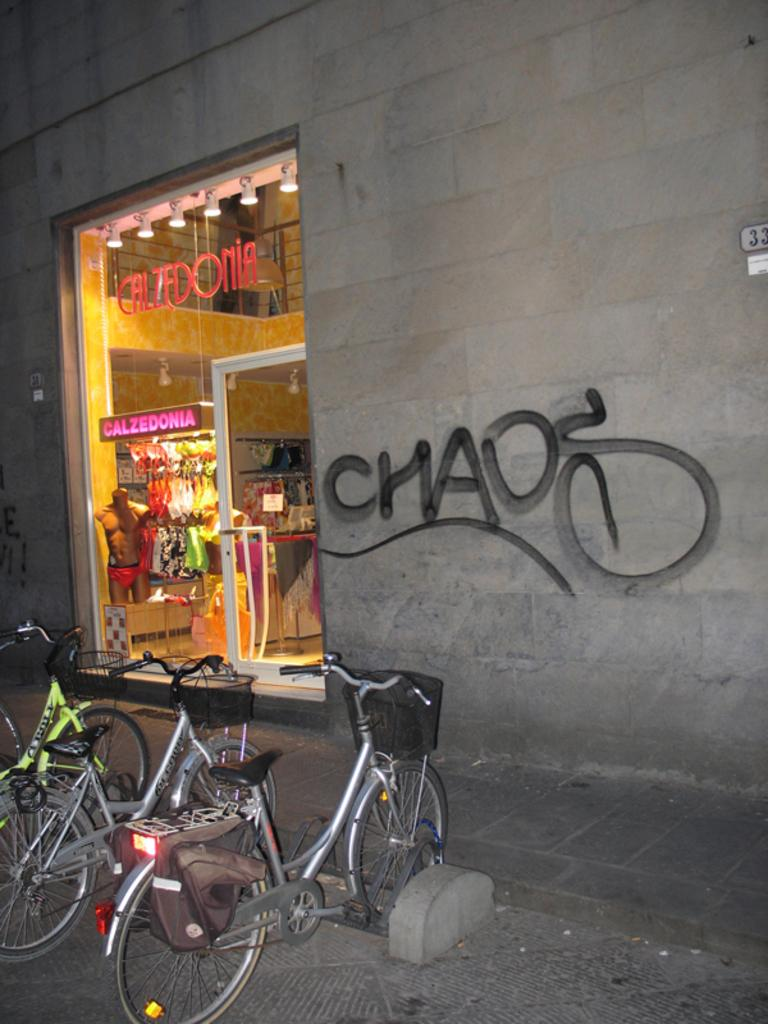How many bicycles are parked in the image? There are three bicycles parked in the image. Where are the bicycles located in relation to the path? The bicycles are near a path in the image. What is located beside the path? There is a shop beside the path. What type of shop is it? The shop is part of a wall and has clothes visible inside. Can you tell me the name of the slave working in the shop in the image? There is no mention of a slave or anyone working in the shop in the image. 